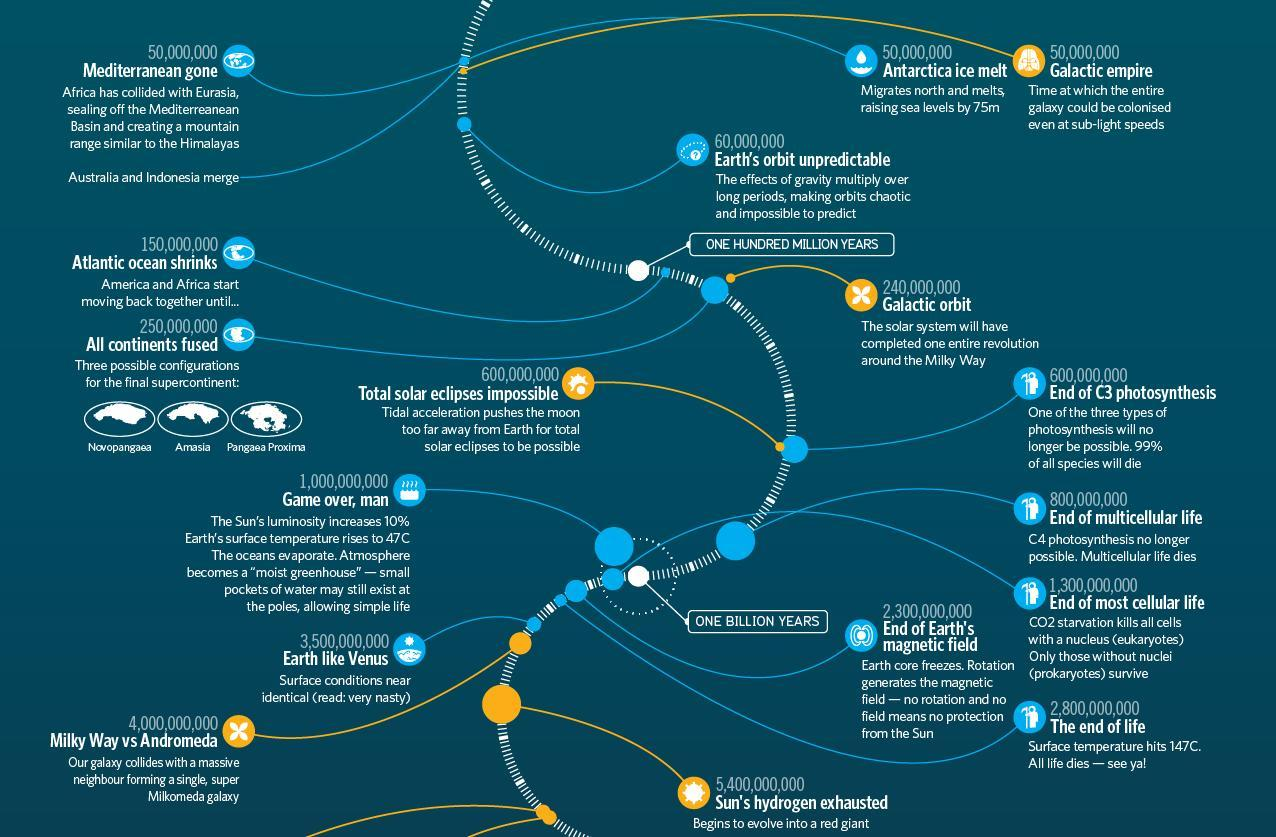Which planet would earth resemble towards the end of its life, Mars, Venus, or Mercury?
Answer the question with a short phrase. Venus Which region has disappeared in 50 million years? Mediterranean Which are the two galaxies that will merge? Milky Way, Andromeda Which year marks the end of cellular life of all forms and kinds? 1,300,000,000 years 